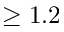Convert formula to latex. <formula><loc_0><loc_0><loc_500><loc_500>\geq 1 . 2</formula> 